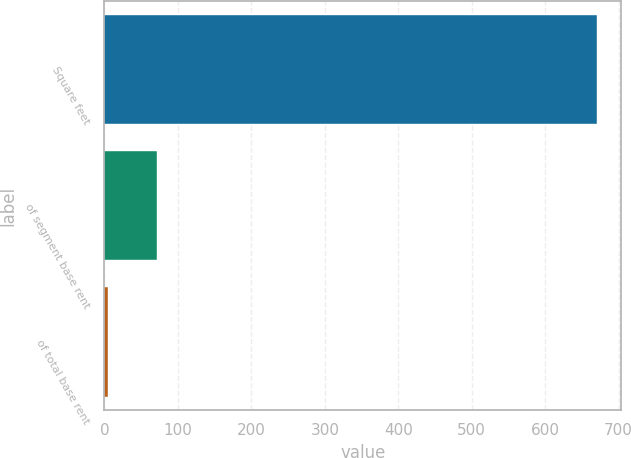Convert chart to OTSL. <chart><loc_0><loc_0><loc_500><loc_500><bar_chart><fcel>Square feet<fcel>of segment base rent<fcel>of total base rent<nl><fcel>670<fcel>71.5<fcel>5<nl></chart> 